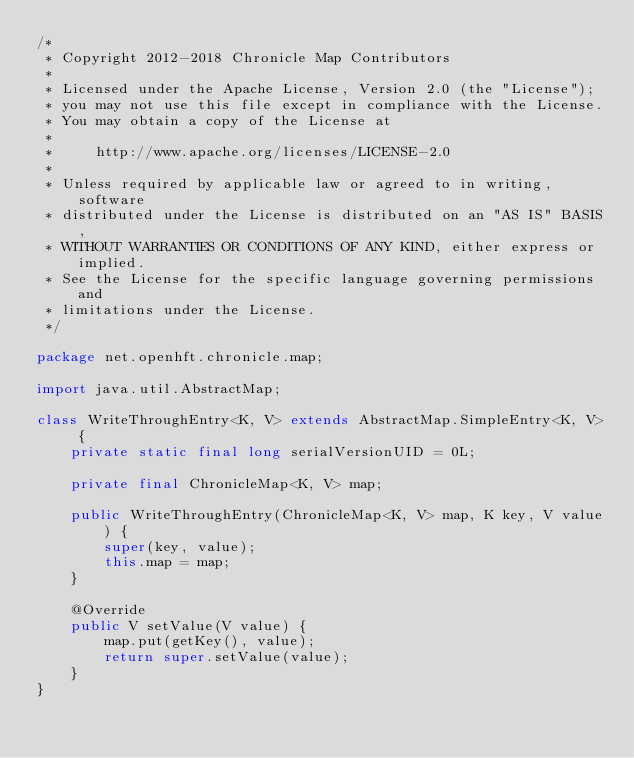Convert code to text. <code><loc_0><loc_0><loc_500><loc_500><_Java_>/*
 * Copyright 2012-2018 Chronicle Map Contributors
 *
 * Licensed under the Apache License, Version 2.0 (the "License");
 * you may not use this file except in compliance with the License.
 * You may obtain a copy of the License at
 *
 *     http://www.apache.org/licenses/LICENSE-2.0
 *
 * Unless required by applicable law or agreed to in writing, software
 * distributed under the License is distributed on an "AS IS" BASIS,
 * WITHOUT WARRANTIES OR CONDITIONS OF ANY KIND, either express or implied.
 * See the License for the specific language governing permissions and
 * limitations under the License.
 */

package net.openhft.chronicle.map;

import java.util.AbstractMap;

class WriteThroughEntry<K, V> extends AbstractMap.SimpleEntry<K, V> {
    private static final long serialVersionUID = 0L;

    private final ChronicleMap<K, V> map;

    public WriteThroughEntry(ChronicleMap<K, V> map, K key, V value) {
        super(key, value);
        this.map = map;
    }

    @Override
    public V setValue(V value) {
        map.put(getKey(), value);
        return super.setValue(value);
    }
}
</code> 